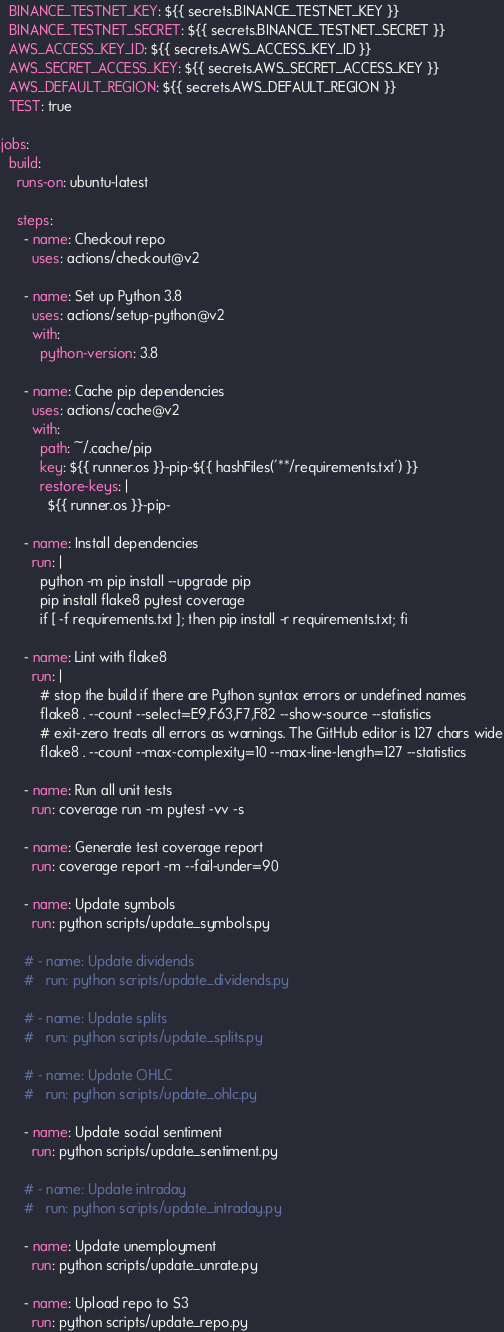<code> <loc_0><loc_0><loc_500><loc_500><_YAML_>  BINANCE_TESTNET_KEY: ${{ secrets.BINANCE_TESTNET_KEY }}
  BINANCE_TESTNET_SECRET: ${{ secrets.BINANCE_TESTNET_SECRET }}
  AWS_ACCESS_KEY_ID: ${{ secrets.AWS_ACCESS_KEY_ID }}
  AWS_SECRET_ACCESS_KEY: ${{ secrets.AWS_SECRET_ACCESS_KEY }}
  AWS_DEFAULT_REGION: ${{ secrets.AWS_DEFAULT_REGION }}
  TEST: true

jobs:
  build:
    runs-on: ubuntu-latest

    steps:
      - name: Checkout repo
        uses: actions/checkout@v2

      - name: Set up Python 3.8
        uses: actions/setup-python@v2
        with:
          python-version: 3.8

      - name: Cache pip dependencies
        uses: actions/cache@v2
        with:
          path: ~/.cache/pip
          key: ${{ runner.os }}-pip-${{ hashFiles('**/requirements.txt') }}
          restore-keys: |
            ${{ runner.os }}-pip-

      - name: Install dependencies
        run: |
          python -m pip install --upgrade pip
          pip install flake8 pytest coverage
          if [ -f requirements.txt ]; then pip install -r requirements.txt; fi

      - name: Lint with flake8
        run: |
          # stop the build if there are Python syntax errors or undefined names
          flake8 . --count --select=E9,F63,F7,F82 --show-source --statistics
          # exit-zero treats all errors as warnings. The GitHub editor is 127 chars wide
          flake8 . --count --max-complexity=10 --max-line-length=127 --statistics

      - name: Run all unit tests
        run: coverage run -m pytest -vv -s

      - name: Generate test coverage report
        run: coverage report -m --fail-under=90

      - name: Update symbols
        run: python scripts/update_symbols.py

      # - name: Update dividends
      #   run: python scripts/update_dividends.py

      # - name: Update splits
      #   run: python scripts/update_splits.py

      # - name: Update OHLC
      #   run: python scripts/update_ohlc.py

      - name: Update social sentiment
        run: python scripts/update_sentiment.py

      # - name: Update intraday
      #   run: python scripts/update_intraday.py

      - name: Update unemployment
        run: python scripts/update_unrate.py

      - name: Upload repo to S3
        run: python scripts/update_repo.py
</code> 